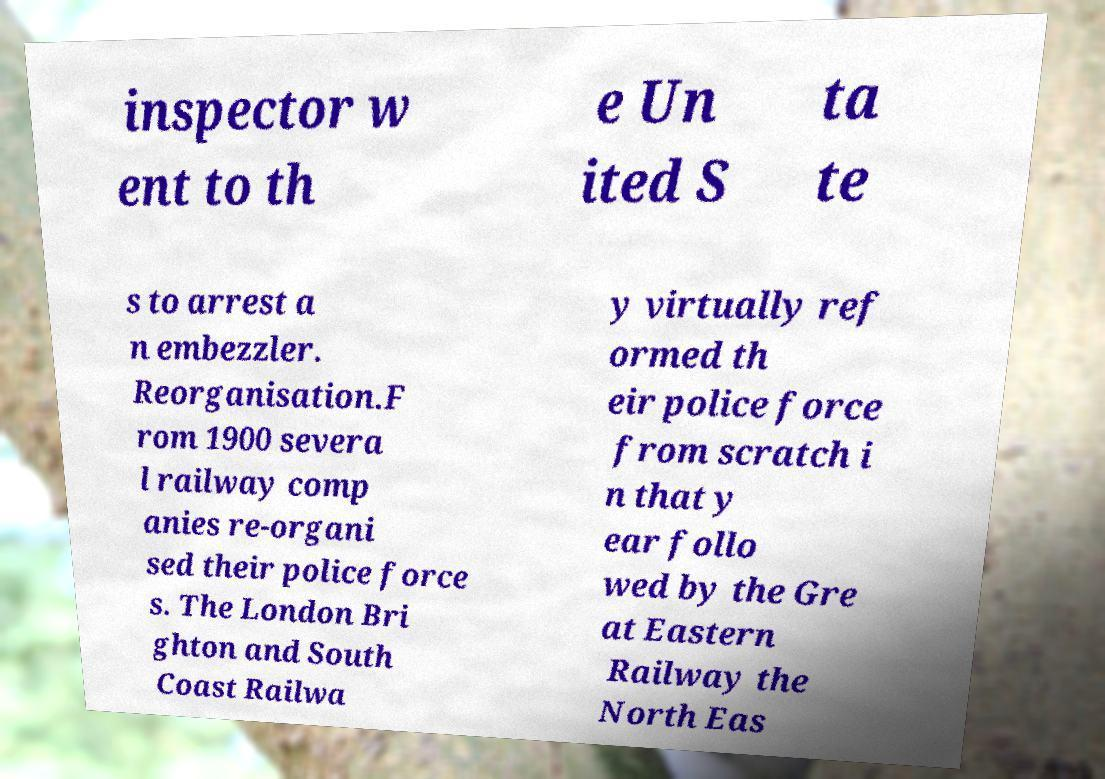Can you read and provide the text displayed in the image?This photo seems to have some interesting text. Can you extract and type it out for me? inspector w ent to th e Un ited S ta te s to arrest a n embezzler. Reorganisation.F rom 1900 severa l railway comp anies re-organi sed their police force s. The London Bri ghton and South Coast Railwa y virtually ref ormed th eir police force from scratch i n that y ear follo wed by the Gre at Eastern Railway the North Eas 